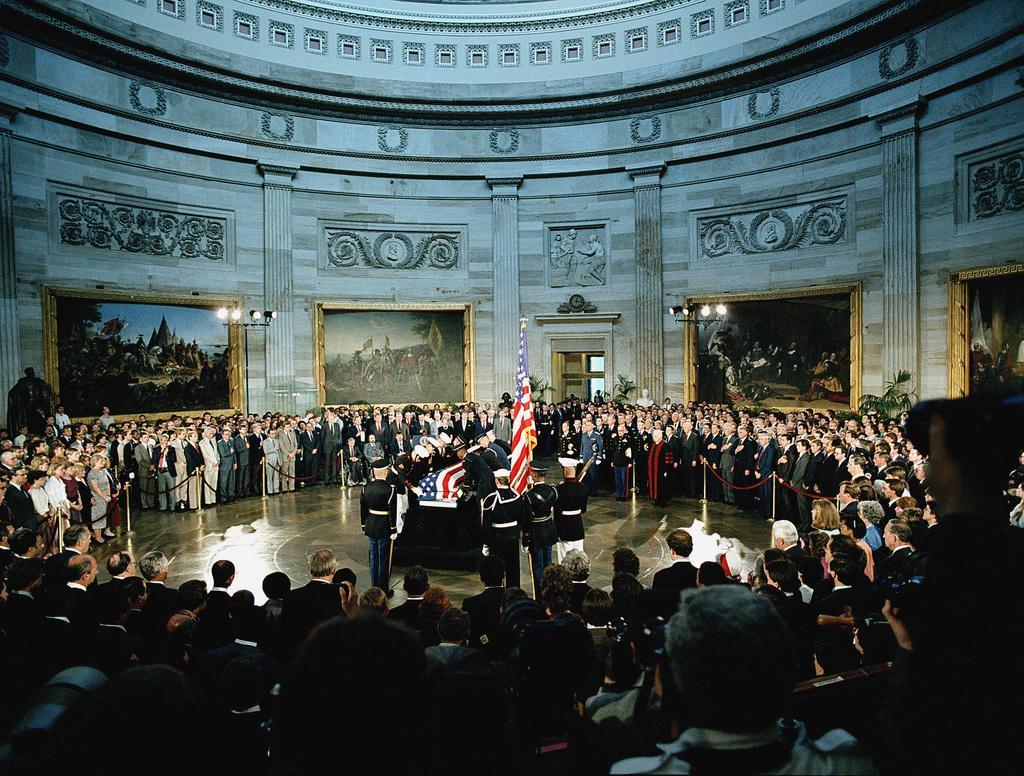Please provide a concise description of this image. This image is clicked inside a room. There are many people standing. In the center there are few people standing. Between them there is a table. Around them there is a rope to the rods. There is a flag to a pole. In the background there is a wall. There are picture frames hanging on the wall. There are lights to the pole. There are sculptures on the wall. 